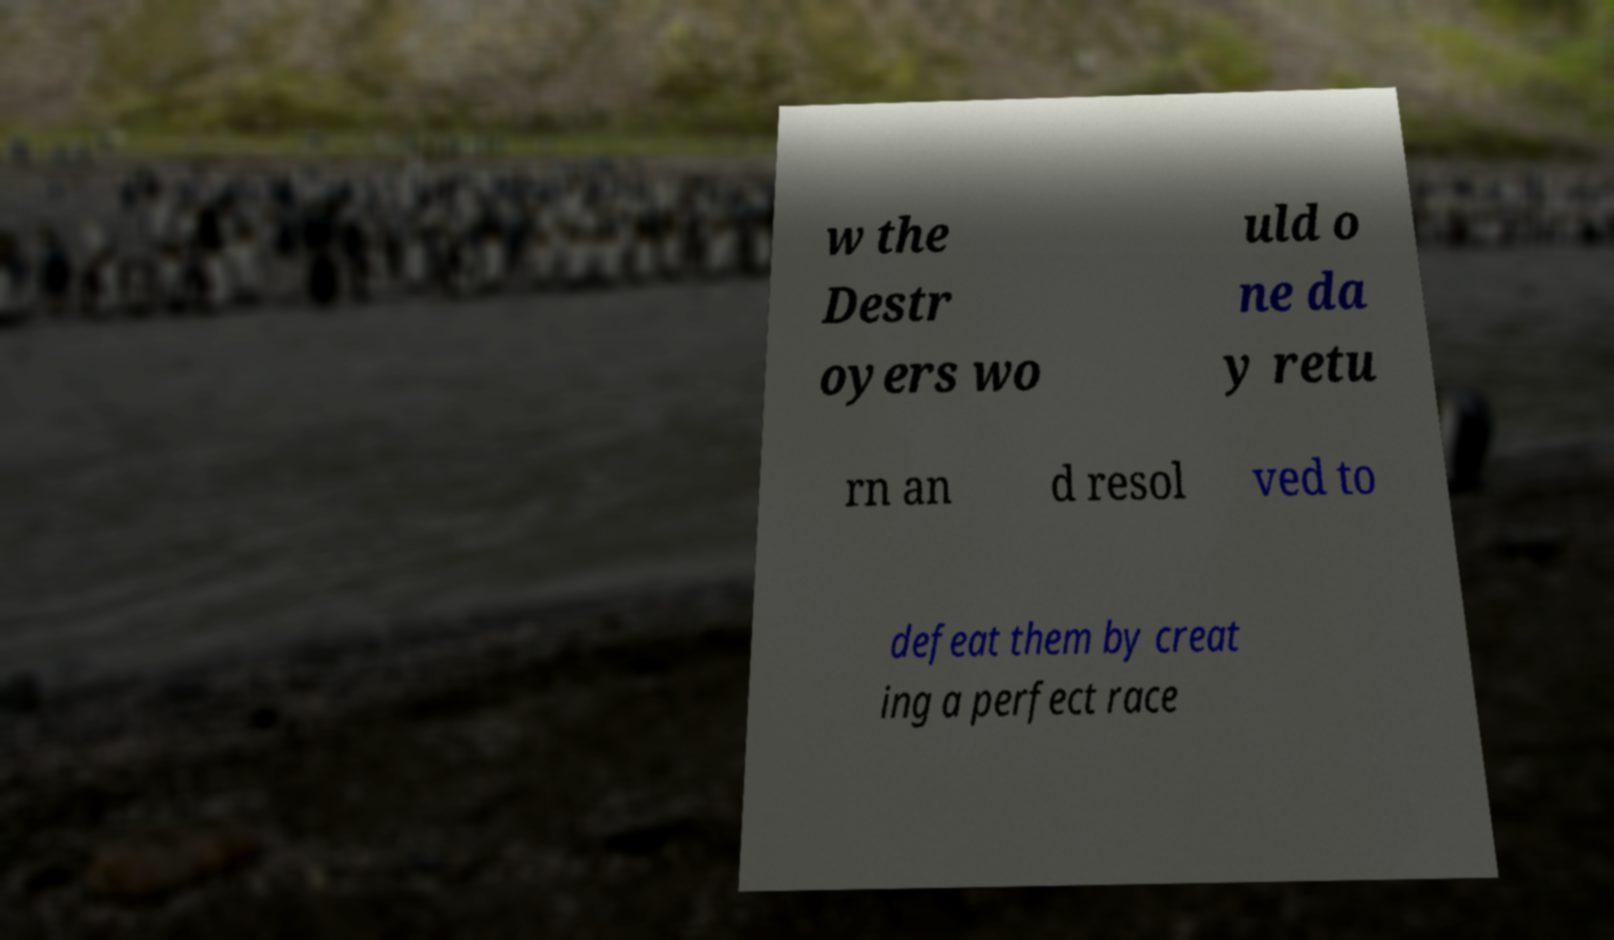Please identify and transcribe the text found in this image. w the Destr oyers wo uld o ne da y retu rn an d resol ved to defeat them by creat ing a perfect race 